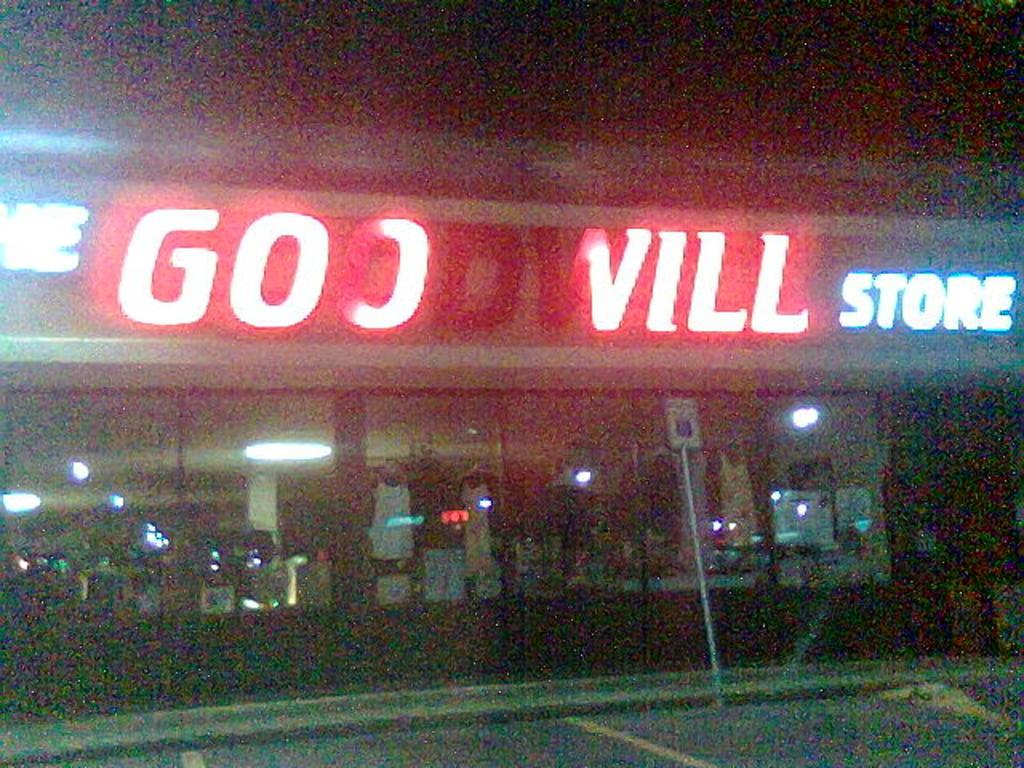What type of establishment is shown in the image? There is a store in the image. What is located in front of the store? There is a board in front of the store. What can be found on the board? There is text on the board. What objects are in the middle of the image? There are glasses in the middle of the image. What can be seen through the glasses? Lights are visible through the glasses. What type of hands are shown holding the glasses in the image? There are no hands visible in the image; it only shows glasses and lights. 